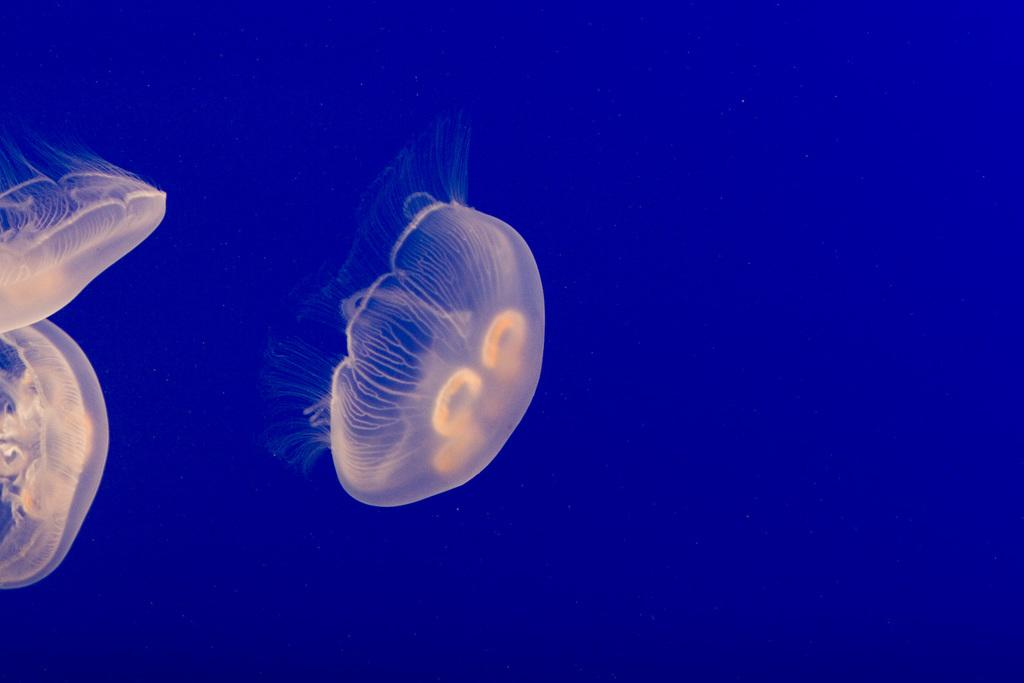What type of sea creatures are in the image? There are jellyfish in the image. What colors are the jellyfish? The jellyfish are yellow and white in color. What color is the background of the image? The background of the image is blue. How many cherries are on the table in the image? There are no cherries or tables present in the image; it features jellyfish in a blue background. What type of balls are being used by the jellyfish in the image? There are no balls present in the image; it features jellyfish in a blue background. 